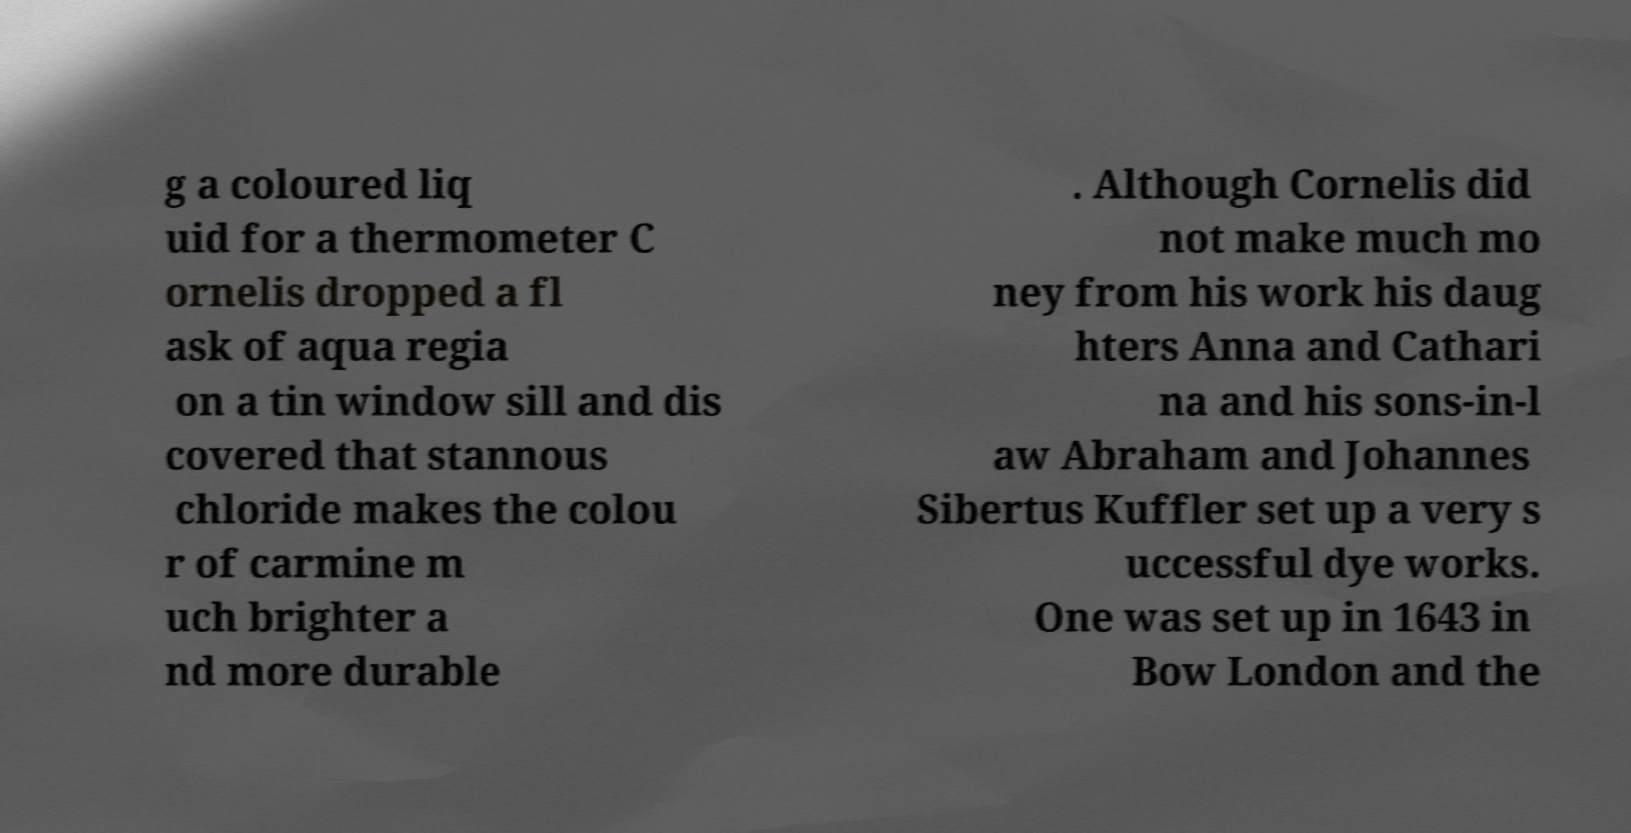For documentation purposes, I need the text within this image transcribed. Could you provide that? g a coloured liq uid for a thermometer C ornelis dropped a fl ask of aqua regia on a tin window sill and dis covered that stannous chloride makes the colou r of carmine m uch brighter a nd more durable . Although Cornelis did not make much mo ney from his work his daug hters Anna and Cathari na and his sons-in-l aw Abraham and Johannes Sibertus Kuffler set up a very s uccessful dye works. One was set up in 1643 in Bow London and the 